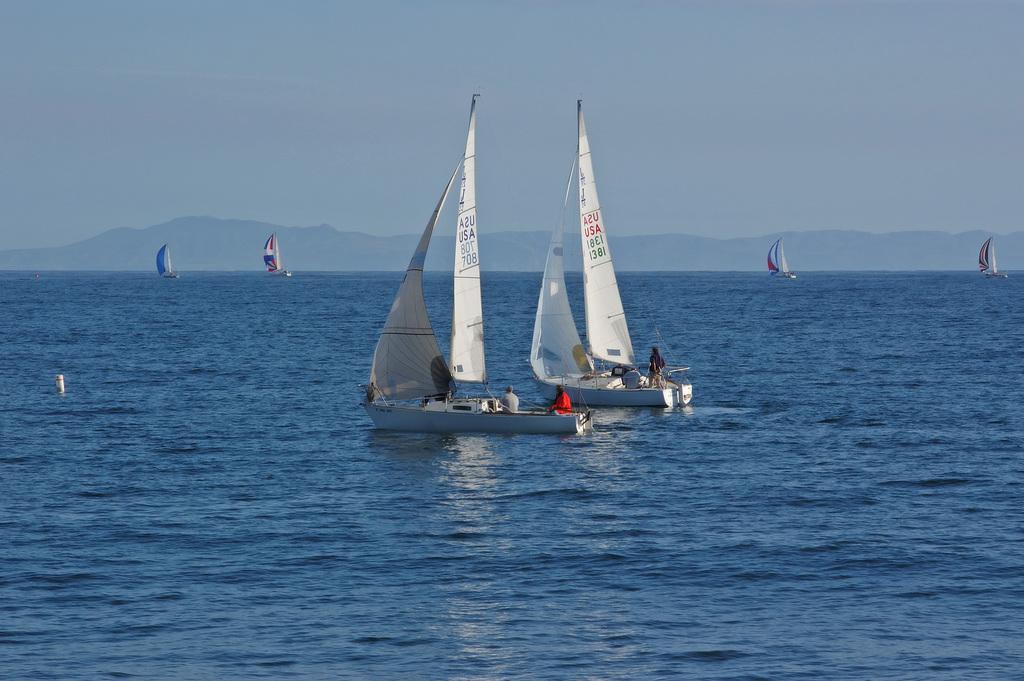Can you describe this image briefly? In the image there are few ships in the ocean and behind there are hills and above its sky. 